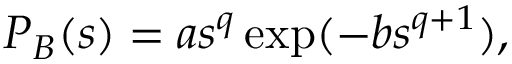<formula> <loc_0><loc_0><loc_500><loc_500>P _ { B } ( s ) = a s ^ { q } \exp ( - b s ^ { q + 1 } ) ,</formula> 